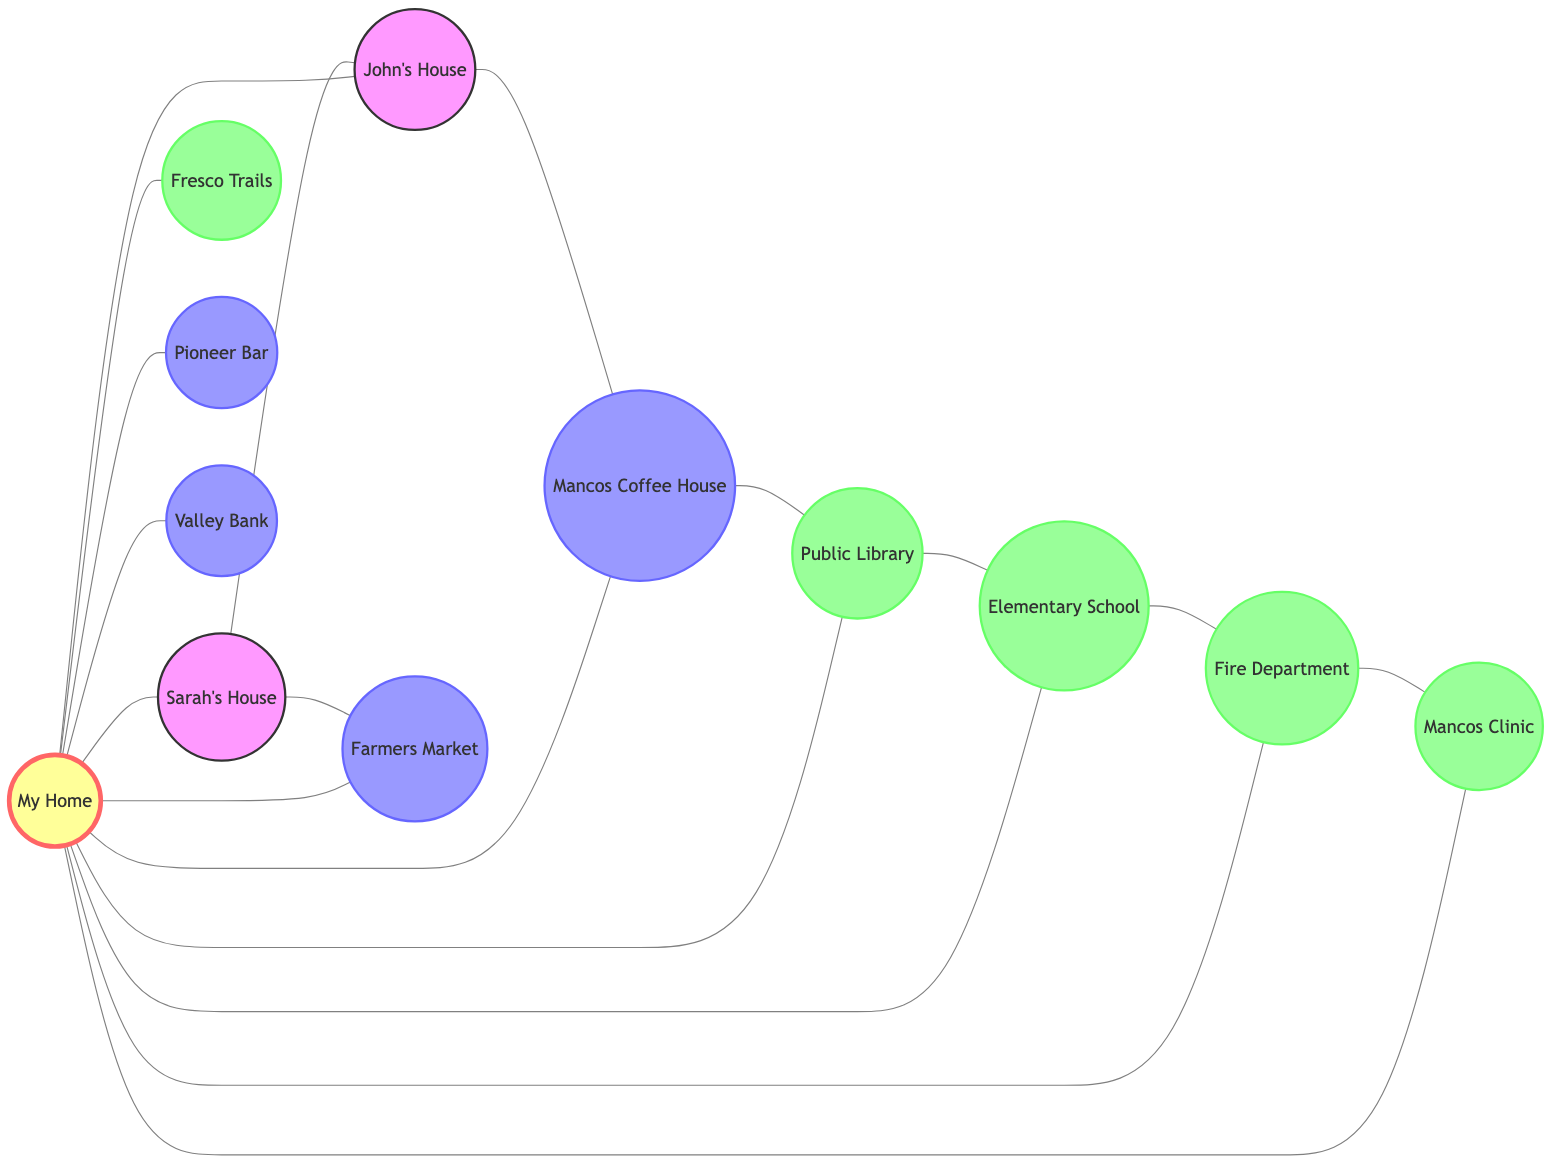What is the total number of nodes in the diagram? The diagram contains multiple nodes, which are entities representing homes, businesses, and community services. To find the total number of nodes, we count all the entities: My Home, Sarah's House, John's House, Mancos Coffee House, Fresco Trails, Mancos Public Library, Mancos Farmers Market, Pioneer Bar, Mancos Valley Bank, Mancos Elementary School, Mancos Volunteer Fire Department, and Mancos Clinic. This adds up to 12 nodes in total.
Answer: 12 How many businesses are represented in the diagram? By analyzing the nodes, we categorize them according to their types. The businesses include Mancos Coffee House, Fresco Trails, Mancos Farmers Market, Pioneer Bar, and Mancos Valley Bank. Counting these gives a total of 5 business nodes.
Answer: 5 What is the relationship label between My Home and Mancos Coffee House? In the diagram, the edge connecting My Home (node 1) to Mancos Coffee House (node 4) is labeled 'Frequent Visitor.' This indicates that there is a strong connection based on recurrent visits.
Answer: Frequent Visitor Which community service is connected to both Mancos Elementary School and Mancos Clinic? We look for nodes that are related to both Mancos Elementary School (node 10) and Mancos Clinic (node 12). The Mancos Volunteer Fire Department (node 11) is linked to both. The relationship between Mancos Elementary School and Mancos Volunteer Fire Department is labeled 'Community Interaction,' and between Mancos Volunteer Fire Department and Mancos Clinic, it is 'Emergency Response.'
Answer: Mancos Volunteer Fire Department How many nodes is Mancos Public Library connected to directly? Checking the connections of Mancos Public Library (node 6), we see that it has direct edges to My Home (node 1), Mancos Coffee House (node 4), and Mancos Elementary School (node 10). Each edge indicates a direct connection, leading to a total of 3 direct connections.
Answer: 3 Which neighbor has a connection to the Farmers Market? Looking at the neighbors listed and their connections, Sarah's House (node 2) has an edge linked to Mancos Farmers Market (node 7) labeled 'Frequent Visitor.' This indicates that Sarah frequently visits the Farmers Market.
Answer: Sarah's House Is there a direct connection between Mancos Coffee House and Mancos Public Library? To determine this, we inspect the connections in the diagram. There is an edge from Mancos Coffee House (node 4) to Mancos Public Library (node 6), labeled 'Nearby.' This indicates they are indeed directly connected.
Answer: Yes What type of connections does My Home have with community services? Reviewing the edges connected to My Home (node 1), we find it links to Mancos Public Library (node 6 as 'Library Member'), Mancos Elementary School (node 10 as 'Community'), Mancos Volunteer Fire Department (node 11 as 'Community'), and Mancos Clinic (node 12 as 'Patient'). Thus, My Home has 4 connections to community services.
Answer: 4 